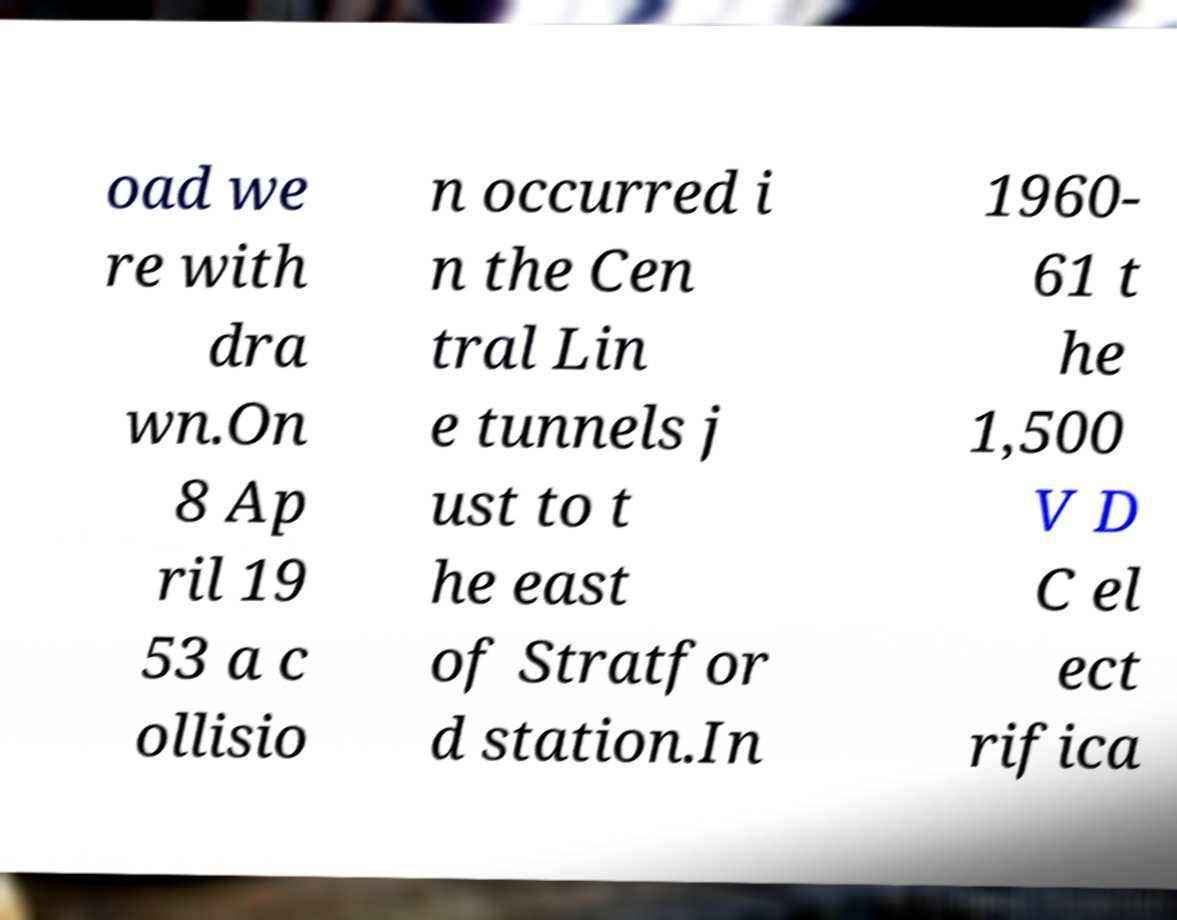Can you accurately transcribe the text from the provided image for me? oad we re with dra wn.On 8 Ap ril 19 53 a c ollisio n occurred i n the Cen tral Lin e tunnels j ust to t he east of Stratfor d station.In 1960- 61 t he 1,500 V D C el ect rifica 